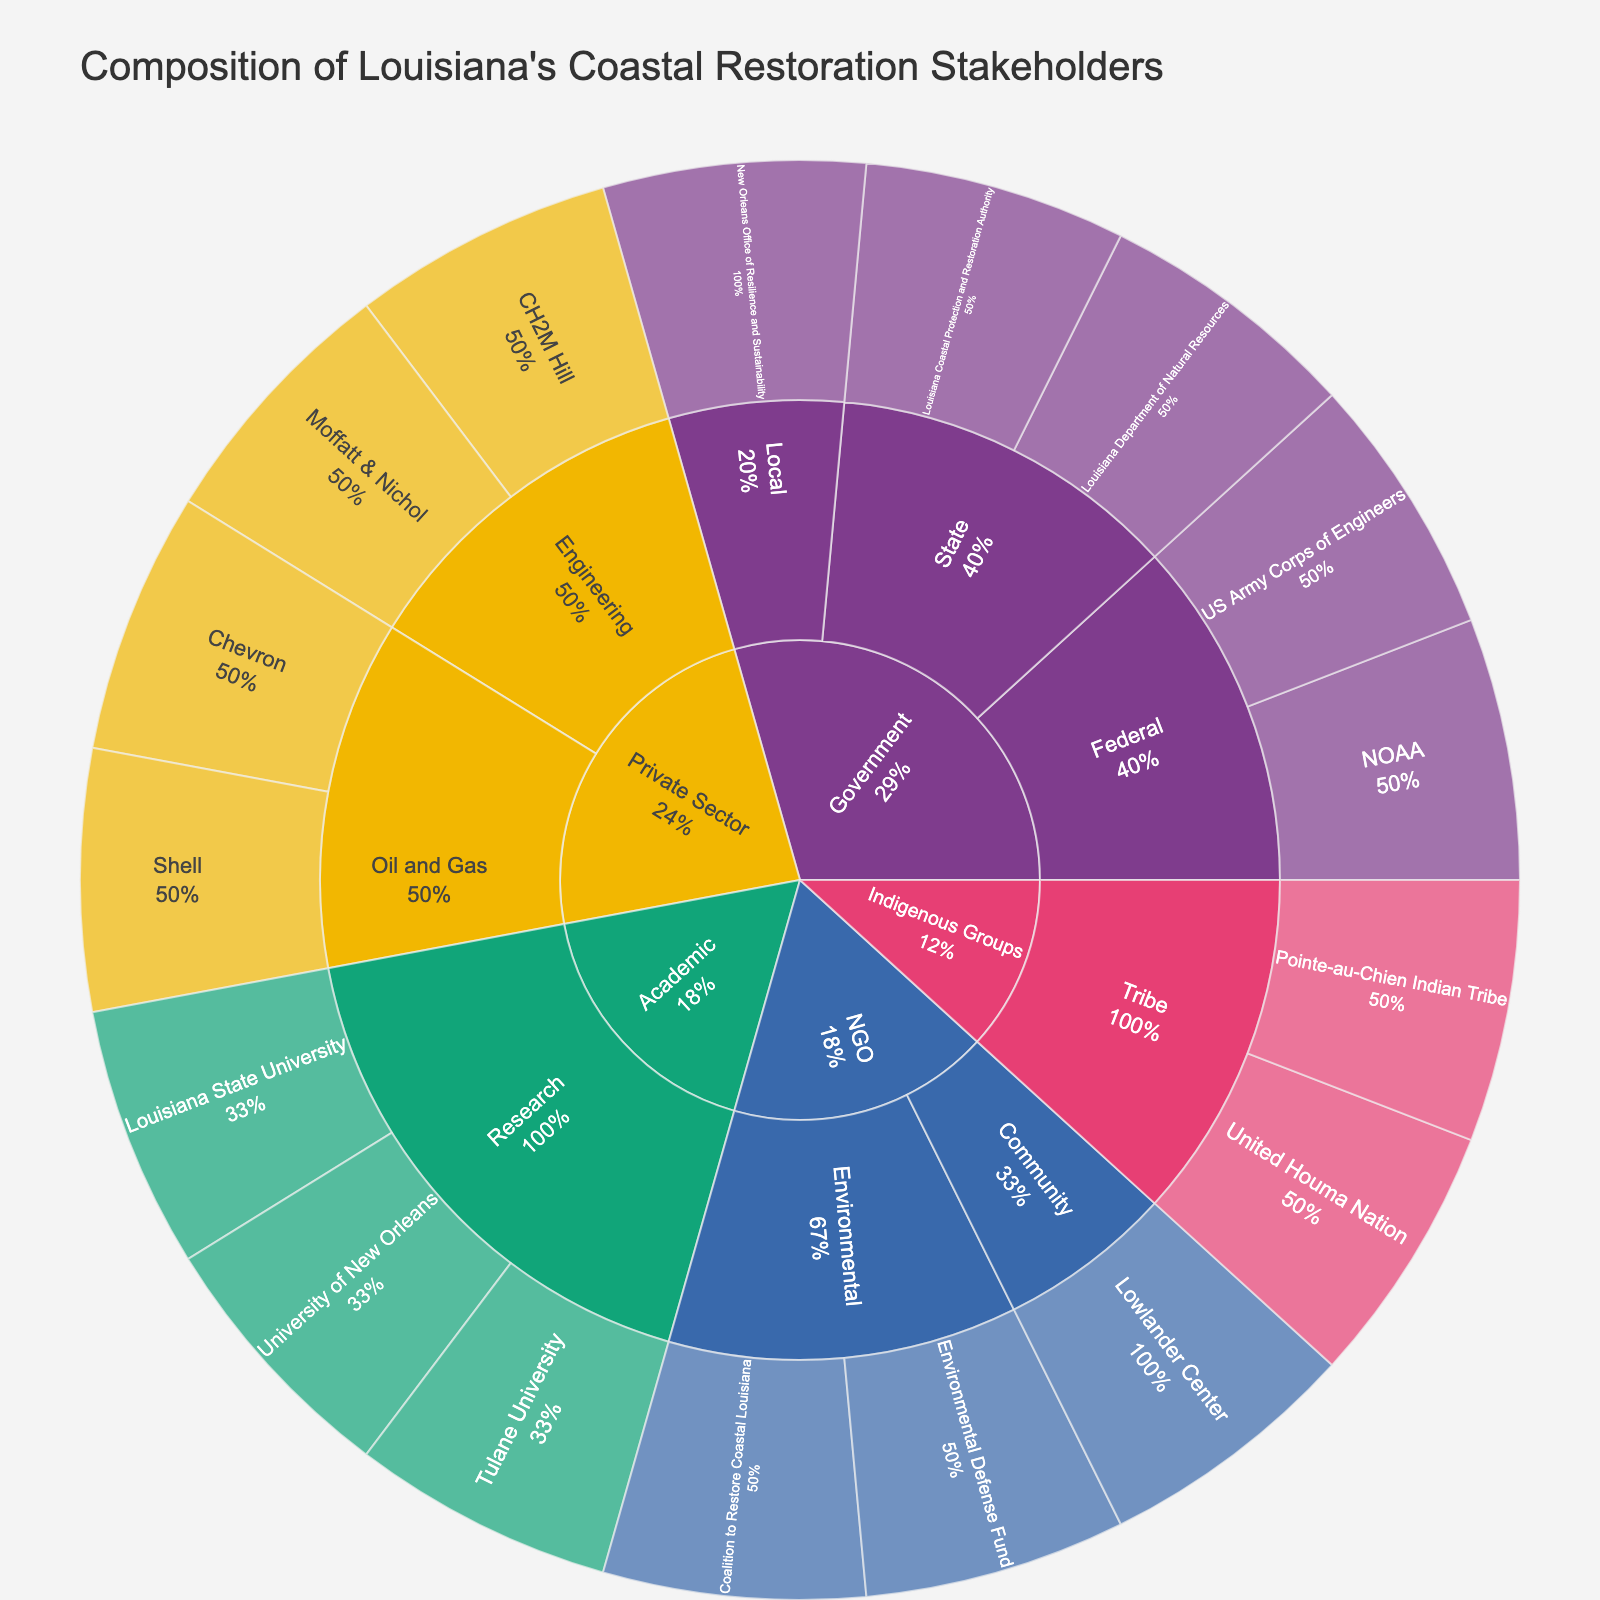What's the title of the plot? The title is usually displayed at the top of the plot and is the most straightforward information.
Answer: Composition of Louisiana's Coastal Restoration Stakeholders How many sectors are represented in the plot? Count the outermost categories in the sunburst plot.
Answer: 5 Which organization is part of both Indigenous Groups and Tribe? Locate the segments that fall under the Indigenous Groups sector and Tribe subsector.
Answer: United Houma Nation, Pointe-au-Chien Indian Tribe What percentage of the plot is occupied by the Private Sector? Look for the label associated with the Private Sector and observe the percentage information provided.
Answer: 25% Compare the number of organizations in the Government sector versus the Academic sector. Which sector has more organizations? Count the wedges under each sector. Government has 5 organizations (US Army Corps of Engineers, NOAA, Louisiana Coastal Protection and Restoration Authority, Louisiana Department of Natural Resources, New Orleans Office of Resilience and Sustainability) whereas Academic has 3 (Louisiana State University, Tulane University, University of New Orleans).
Answer: Government Which subsector within the Government sector has the highest percentage of involvement? Look within the Government sector and identify subsectors, then determine which has the largest visual area and percentage label.
Answer: Federal Identify all the sectors that NOAA is involved in. Locate NOAA in the plot and trace back to its sector to identify involvement.
Answer: Government Among the NGO sector organizations, which one focuses on community-oriented work? Look within the NGO sector and locate the community-oriented organization.
Answer: Lowlander Center How does the involvement of environmental NGOs compare to community NGOs? Count the number of environmental and community NGOs in the plot. There are 2 environmental (Environmental Defense Fund, Coalition to Restore Coastal Louisiana) and 1 community (Lowlander Center).
Answer: More environmental NGOs Are there more organizations in the Oil and Gas subsector or the Engineering subsector within the Private Sector? Count the organizations in each subsector in the Private Sector: Oil and Gas (2: Shell, Chevron) and Engineering (2: CH2M Hill, Moffatt & Nichol).
Answer: Equal 